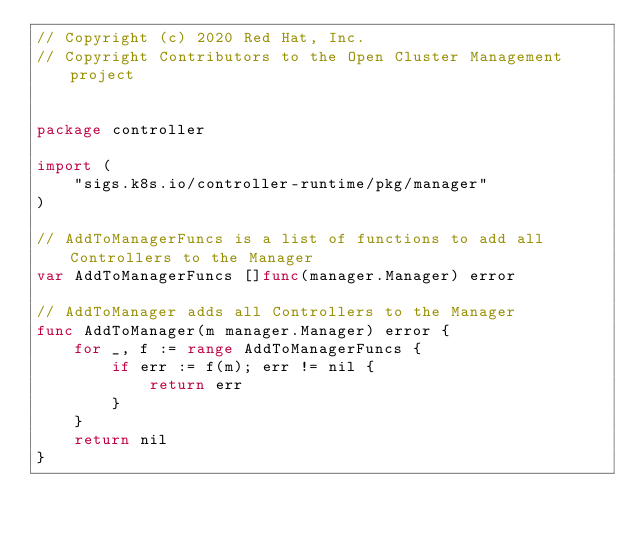Convert code to text. <code><loc_0><loc_0><loc_500><loc_500><_Go_>// Copyright (c) 2020 Red Hat, Inc.
// Copyright Contributors to the Open Cluster Management project


package controller

import (
	"sigs.k8s.io/controller-runtime/pkg/manager"
)

// AddToManagerFuncs is a list of functions to add all Controllers to the Manager
var AddToManagerFuncs []func(manager.Manager) error

// AddToManager adds all Controllers to the Manager
func AddToManager(m manager.Manager) error {
	for _, f := range AddToManagerFuncs {
		if err := f(m); err != nil {
			return err
		}
	}
	return nil
}
</code> 